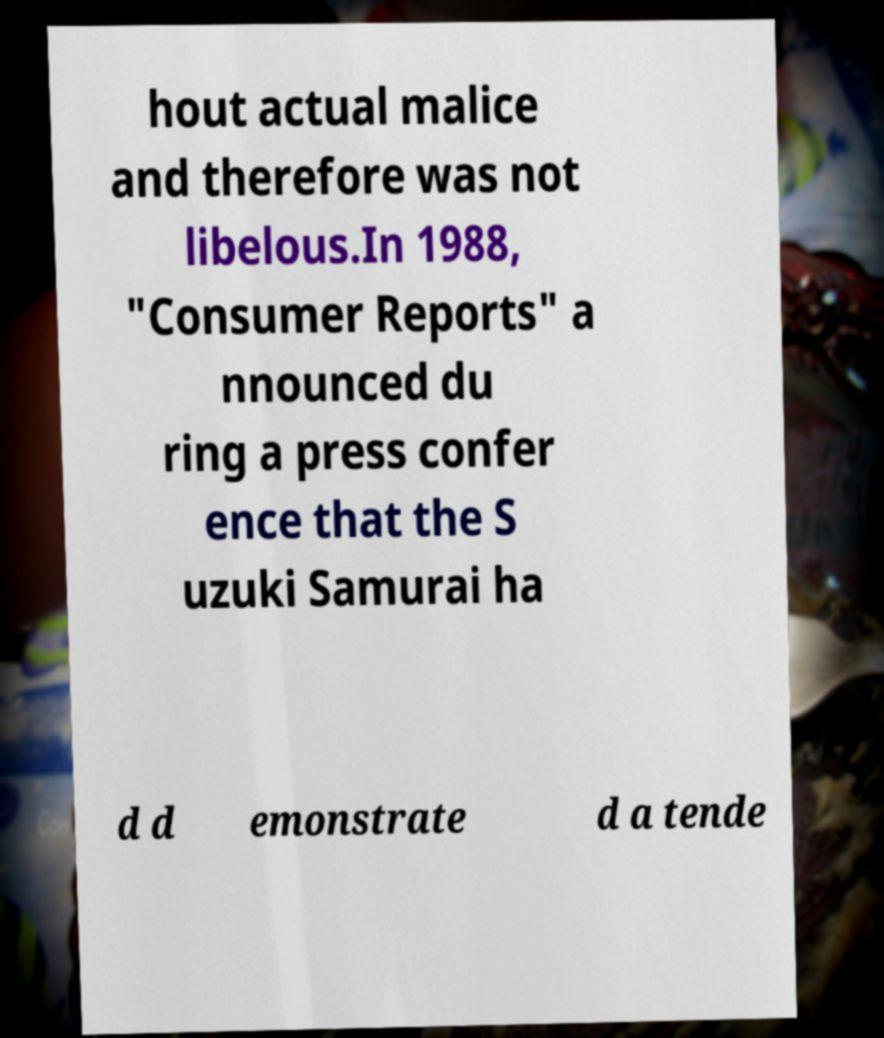Could you extract and type out the text from this image? hout actual malice and therefore was not libelous.In 1988, "Consumer Reports" a nnounced du ring a press confer ence that the S uzuki Samurai ha d d emonstrate d a tende 